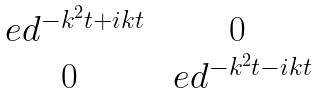Convert formula to latex. <formula><loc_0><loc_0><loc_500><loc_500>\begin{matrix} \ e d ^ { - k ^ { 2 } t + i k t } & 0 \\ 0 & \ e d ^ { - k ^ { 2 } t - i k t } \end{matrix}</formula> 